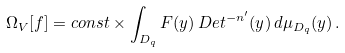<formula> <loc_0><loc_0><loc_500><loc_500>\Omega _ { V } [ f ] = c o n s t \times \int _ { D _ { q } } F ( y ) \, D e t ^ { - n ^ { \prime } } ( y ) \, d \mu _ { D _ { q } } ( y ) \, .</formula> 